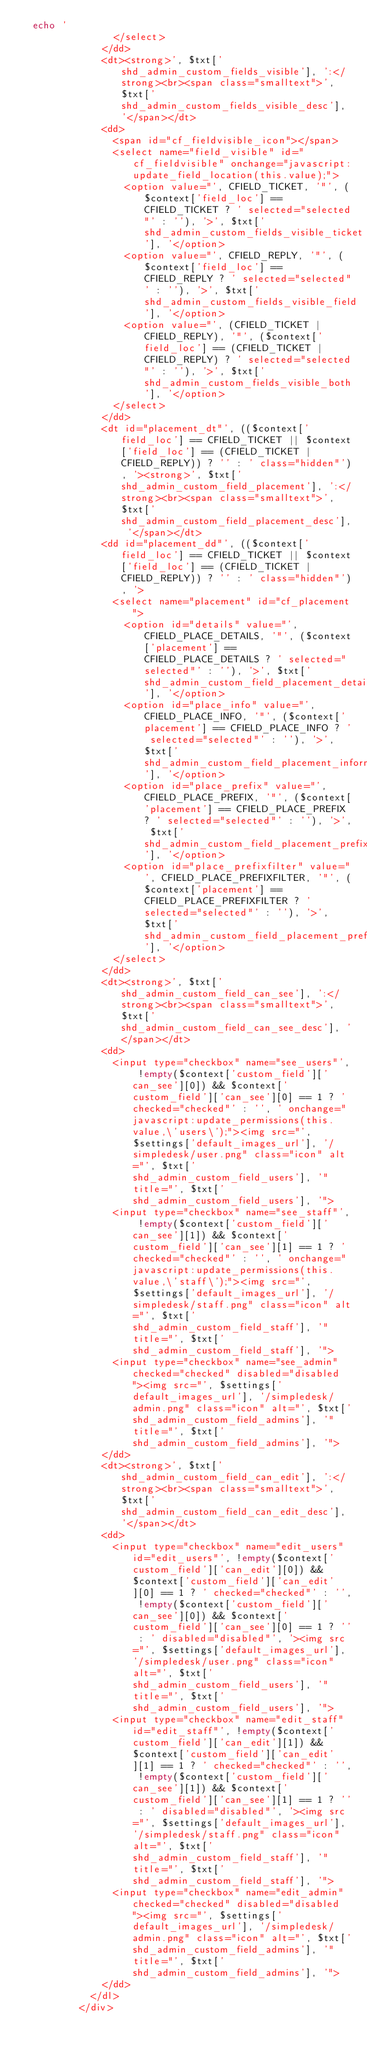Convert code to text. <code><loc_0><loc_0><loc_500><loc_500><_PHP_>	echo '
								</select>
							</dd>
							<dt><strong>', $txt['shd_admin_custom_fields_visible'], ':</strong><br><span class="smalltext">', $txt['shd_admin_custom_fields_visible_desc'], '</span></dt>
							<dd>
								<span id="cf_fieldvisible_icon"></span>
								<select name="field_visible" id="cf_fieldvisible" onchange="javascript:update_field_location(this.value);">
									<option value="', CFIELD_TICKET, '"', ($context['field_loc'] == CFIELD_TICKET ? ' selected="selected"' : ''), '>', $txt['shd_admin_custom_fields_visible_ticket'], '</option>
									<option value="', CFIELD_REPLY, '"', ($context['field_loc'] == CFIELD_REPLY ? ' selected="selected"' : ''), '>', $txt['shd_admin_custom_fields_visible_field'], '</option>
									<option value="', (CFIELD_TICKET | CFIELD_REPLY), '"', ($context['field_loc'] == (CFIELD_TICKET | CFIELD_REPLY) ? ' selected="selected"' : ''), '>', $txt['shd_admin_custom_fields_visible_both'], '</option>
								</select>
							</dd>
							<dt id="placement_dt"', (($context['field_loc'] == CFIELD_TICKET || $context['field_loc'] == (CFIELD_TICKET | CFIELD_REPLY)) ? '' : ' class="hidden"'), '><strong>', $txt['shd_admin_custom_field_placement'], ':</strong><br><span class="smalltext">', $txt['shd_admin_custom_field_placement_desc'], '</span></dt>
							<dd id="placement_dd"', (($context['field_loc'] == CFIELD_TICKET || $context['field_loc'] == (CFIELD_TICKET | CFIELD_REPLY)) ? '' : ' class="hidden"'), '>
								<select name="placement" id="cf_placement">
									<option id="details" value="', CFIELD_PLACE_DETAILS, '"', ($context['placement'] == CFIELD_PLACE_DETAILS ? ' selected="selected"' : ''), '>', $txt['shd_admin_custom_field_placement_details'], '</option>
									<option id="place_info" value="', CFIELD_PLACE_INFO, '"', ($context['placement'] == CFIELD_PLACE_INFO ? ' selected="selected"' : ''), '>', $txt['shd_admin_custom_field_placement_information'], '</option>
									<option id="place_prefix" value="', CFIELD_PLACE_PREFIX, '"', ($context['placement'] == CFIELD_PLACE_PREFIX ? ' selected="selected"' : ''), '>', $txt['shd_admin_custom_field_placement_prefix'], '</option>
									<option id="place_prefixfilter" value="', CFIELD_PLACE_PREFIXFILTER, '"', ($context['placement'] == CFIELD_PLACE_PREFIXFILTER ? ' selected="selected"' : ''), '>', $txt['shd_admin_custom_field_placement_prefixfilter'], '</option>
								</select>
							</dd>
							<dt><strong>', $txt['shd_admin_custom_field_can_see'], ':</strong><br><span class="smalltext">', $txt['shd_admin_custom_field_can_see_desc'], '</span></dt>
							<dd>
								<input type="checkbox" name="see_users"', !empty($context['custom_field']['can_see'][0]) && $context['custom_field']['can_see'][0] == 1 ? ' checked="checked"' : '', ' onchange="javascript:update_permissions(this.value,\'users\');"><img src="', $settings['default_images_url'], '/simpledesk/user.png" class="icon" alt="', $txt['shd_admin_custom_field_users'], '" title="', $txt['shd_admin_custom_field_users'], '">
								<input type="checkbox" name="see_staff"', !empty($context['custom_field']['can_see'][1]) && $context['custom_field']['can_see'][1] == 1 ? ' checked="checked"' : '', ' onchange="javascript:update_permissions(this.value,\'staff\');"><img src="', $settings['default_images_url'], '/simpledesk/staff.png" class="icon" alt="', $txt['shd_admin_custom_field_staff'], '" title="', $txt['shd_admin_custom_field_staff'], '">
								<input type="checkbox" name="see_admin" checked="checked" disabled="disabled"><img src="', $settings['default_images_url'], '/simpledesk/admin.png" class="icon" alt="', $txt['shd_admin_custom_field_admins'], '" title="', $txt['shd_admin_custom_field_admins'], '">
							</dd>
							<dt><strong>', $txt['shd_admin_custom_field_can_edit'], ':</strong><br><span class="smalltext">', $txt['shd_admin_custom_field_can_edit_desc'], '</span></dt>
							<dd>
								<input type="checkbox" name="edit_users" id="edit_users"', !empty($context['custom_field']['can_edit'][0]) && $context['custom_field']['can_edit'][0] == 1 ? ' checked="checked"' : '', !empty($context['custom_field']['can_see'][0]) && $context['custom_field']['can_see'][0] == 1 ? '' : ' disabled="disabled"', '><img src="', $settings['default_images_url'], '/simpledesk/user.png" class="icon" alt="', $txt['shd_admin_custom_field_users'], '" title="', $txt['shd_admin_custom_field_users'], '">
								<input type="checkbox" name="edit_staff" id="edit_staff"', !empty($context['custom_field']['can_edit'][1]) && $context['custom_field']['can_edit'][1] == 1 ? ' checked="checked"' : '', !empty($context['custom_field']['can_see'][1]) && $context['custom_field']['can_see'][1] == 1 ? '' : ' disabled="disabled"', '><img src="', $settings['default_images_url'], '/simpledesk/staff.png" class="icon" alt="', $txt['shd_admin_custom_field_staff'], '" title="', $txt['shd_admin_custom_field_staff'], '">
								<input type="checkbox" name="edit_admin" checked="checked" disabled="disabled"><img src="', $settings['default_images_url'], '/simpledesk/admin.png" class="icon" alt="', $txt['shd_admin_custom_field_admins'], '" title="', $txt['shd_admin_custom_field_admins'], '">
							</dd>
						</dl>
					</div></code> 